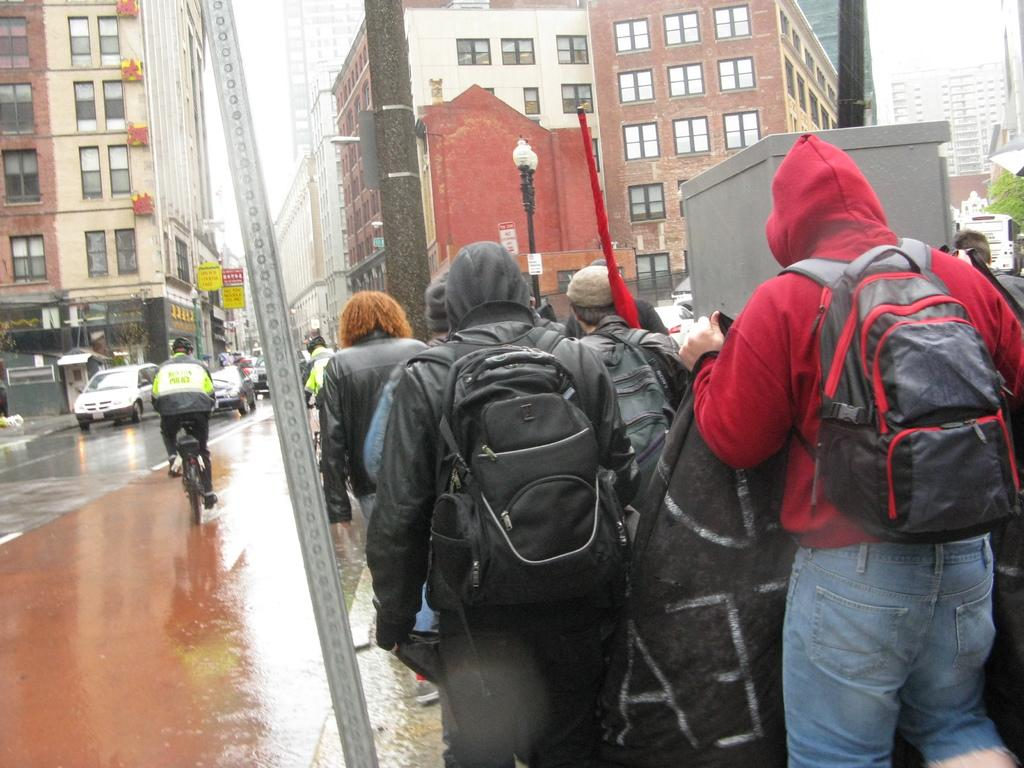What are the people in the image wearing? The people in the image are wearing jackets. What activity is the man in the image engaged in? The man is riding a bicycle on the road. What can be seen in the background of the image? There is a building and cars visible in the background. What type of grain is being harvested in the image? There is no grain present in the image; it features people wearing jackets, a man riding a bicycle, and a building in the background. 